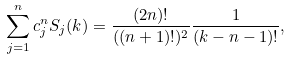<formula> <loc_0><loc_0><loc_500><loc_500>\sum _ { j = 1 } ^ { n } c _ { j } ^ { n } S _ { j } ( k ) = \frac { ( 2 n ) ! } { ( ( n + 1 ) ! ) ^ { 2 } } \frac { 1 } { ( k - n - 1 ) ! } ,</formula> 